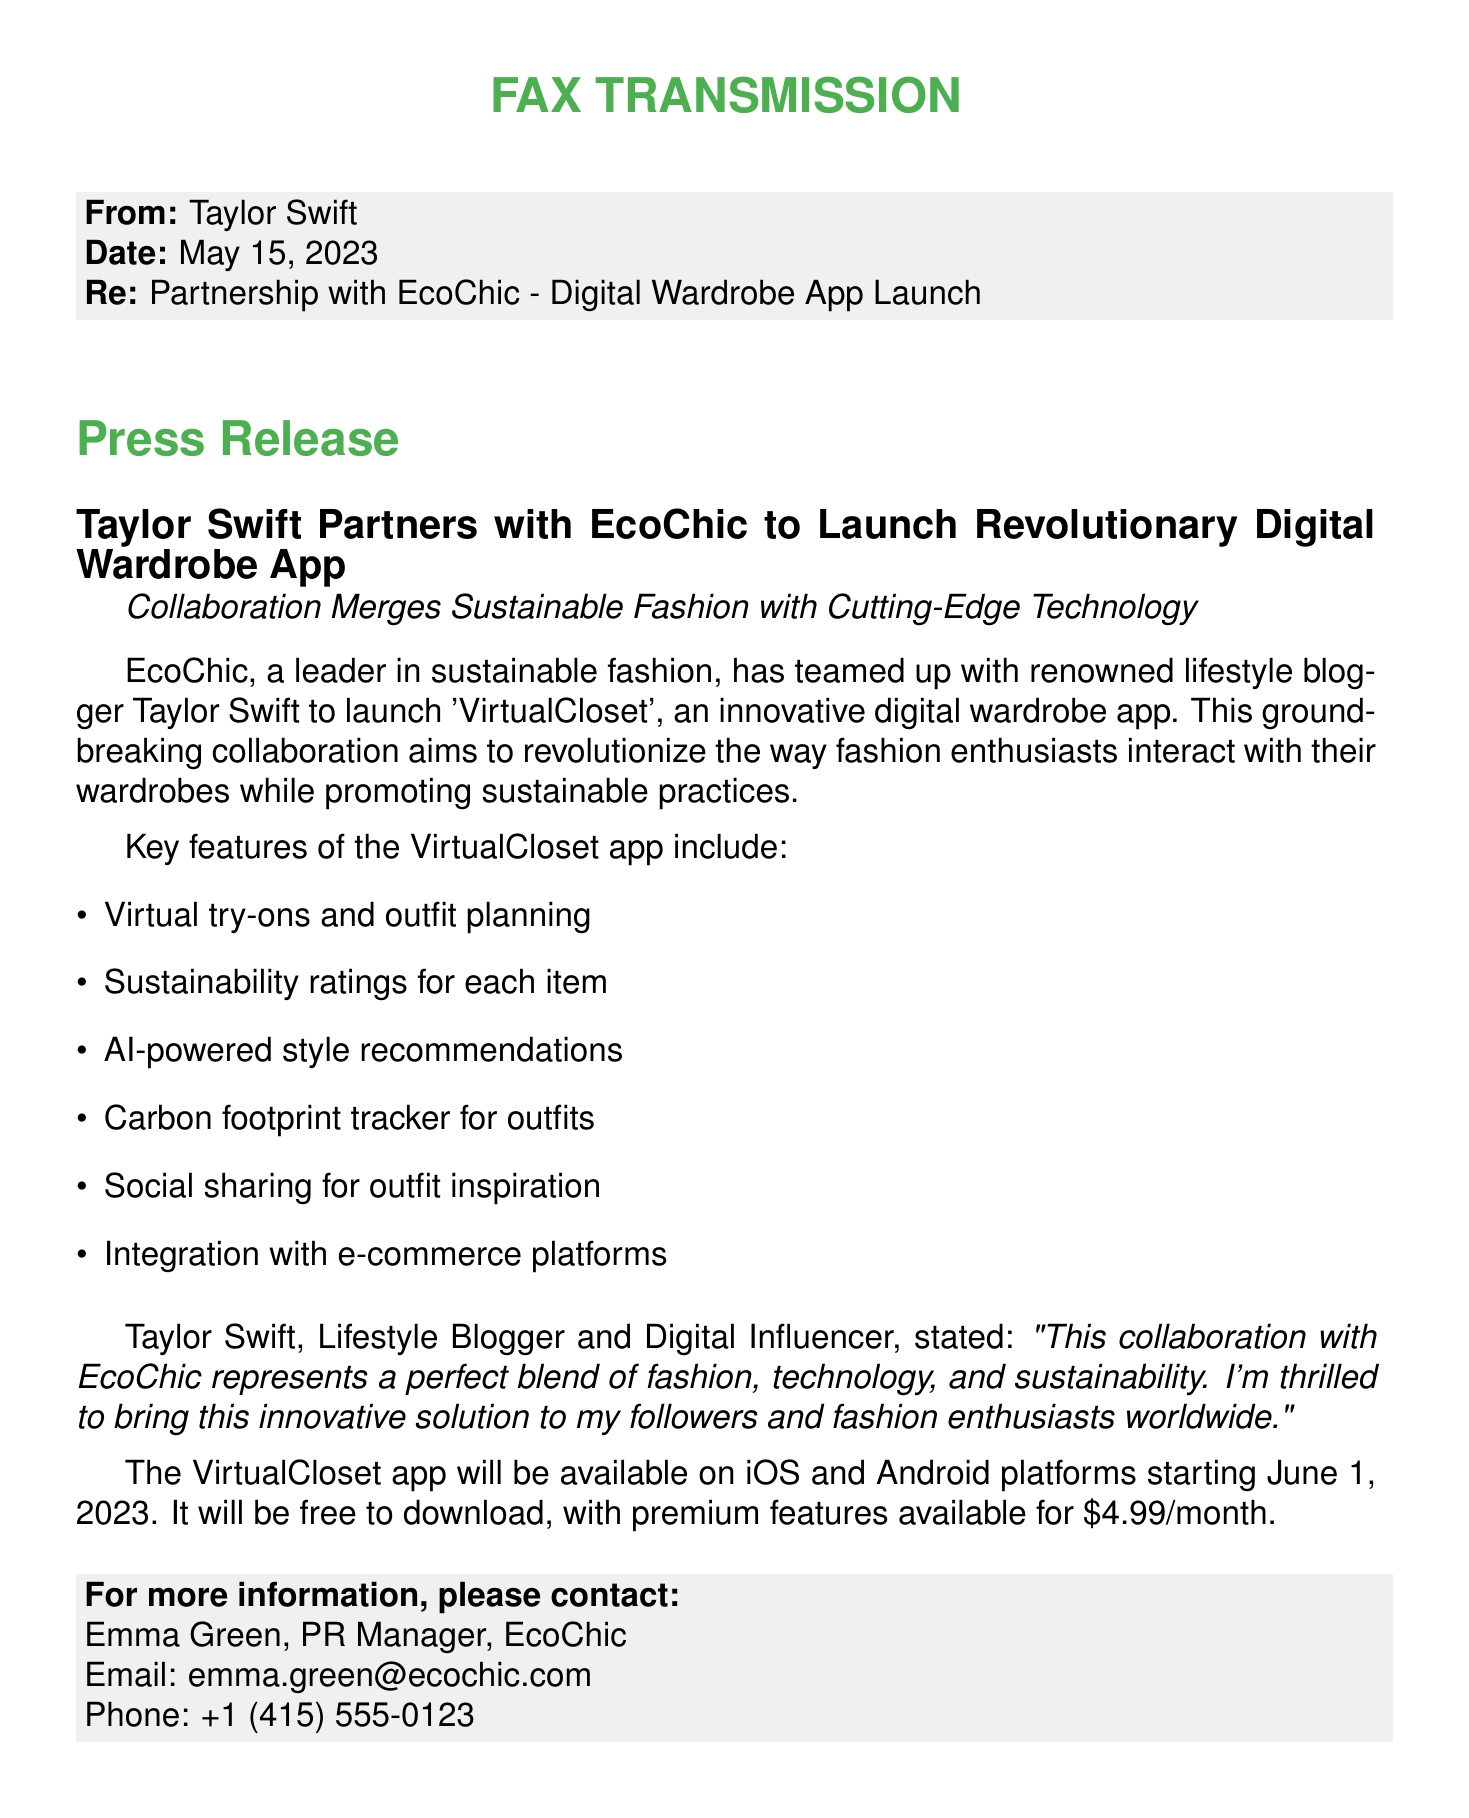What is the name of the app? The document states that the app is called 'VirtualCloset'.
Answer: VirtualCloset Who is partnering with EcoChic? The document mentions that Taylor Swift is partnering with EcoChic.
Answer: Taylor Swift What is the release date of the app? According to the document, the app will be available starting June 1, 2023.
Answer: June 1, 2023 How much do the premium features cost? The document indicates that premium features are available for $4.99/month.
Answer: $4.99/month What feature allows users to plan outfits? The document lists 'outfit planning' as a key feature of the app.
Answer: outfit planning What technology does the app use for recommendations? The document states the app uses AI for style recommendations.
Answer: AI What is the main focus of the collaboration? The document emphasizes that the collaboration focuses on merging fashion, technology, and sustainability.
Answer: sustainability Who is the PR Manager mentioned in the document? The document provides the name Emma Green as the PR Manager for EcoChic.
Answer: Emma Green What is one of the sustainability features of the app? The document states a key feature is a carbon footprint tracker for outfits.
Answer: carbon footprint tracker 